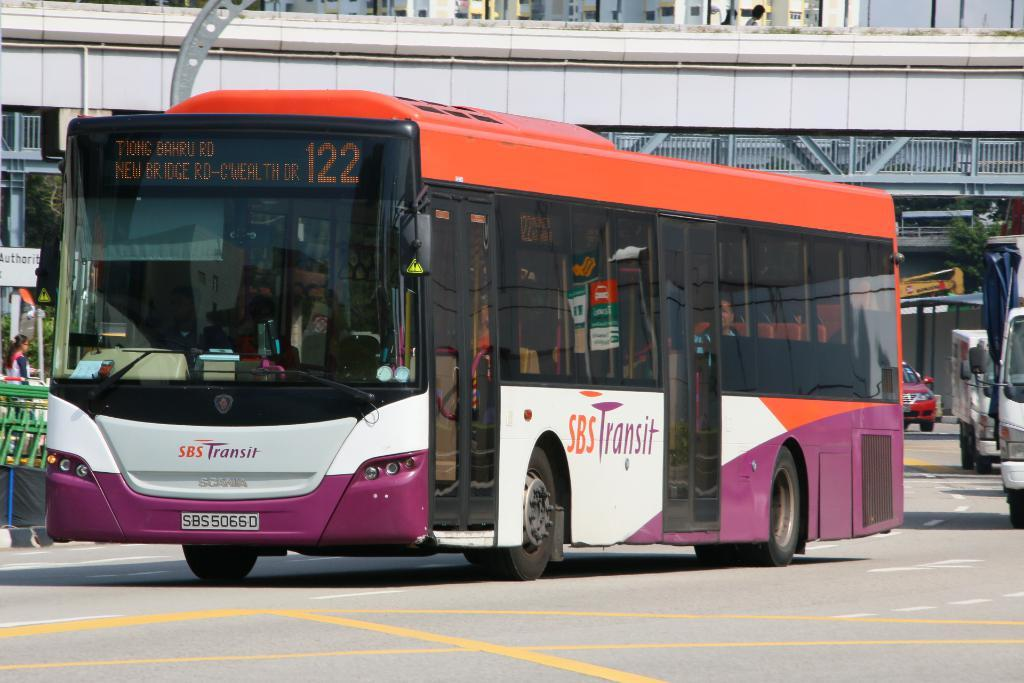Provide a one-sentence caption for the provided image. A purple, orange and white bus for SBS Transit is numbered 122. 